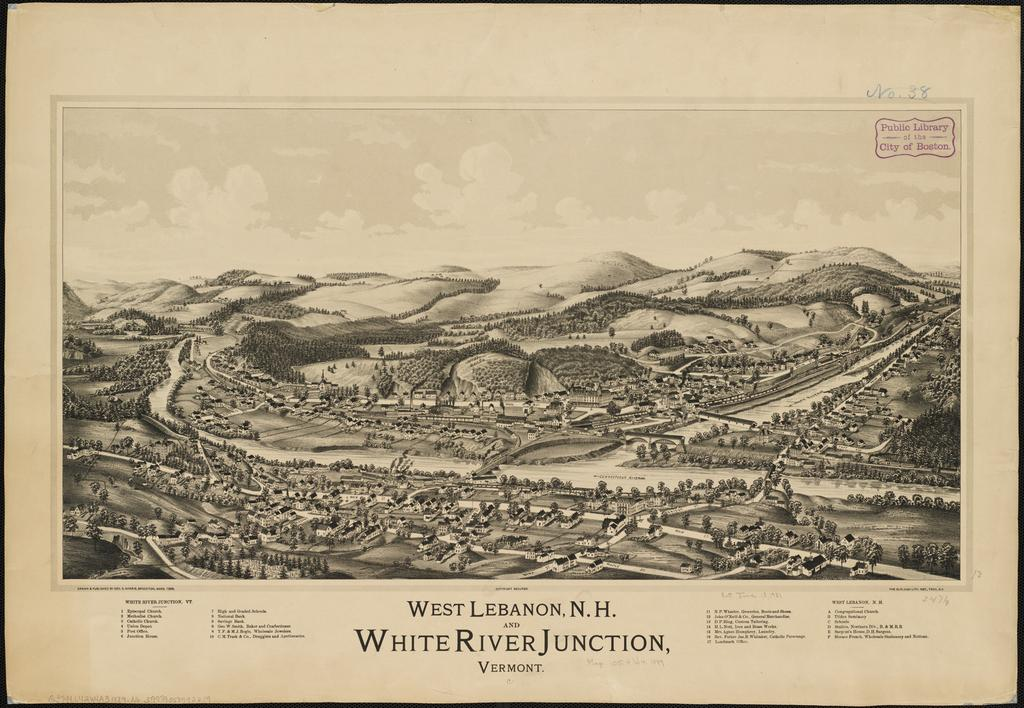<image>
Provide a brief description of the given image. A old black and white city map of White River Junction. 